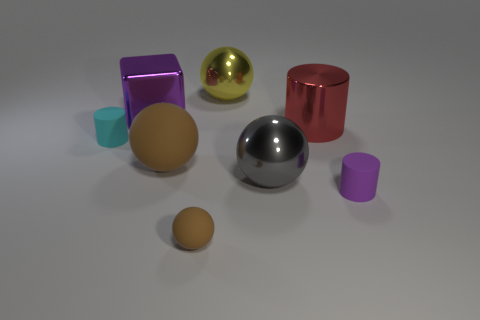Subtract all large brown balls. How many balls are left? 3 Subtract 1 blocks. How many blocks are left? 0 Add 1 big yellow matte blocks. How many objects exist? 9 Subtract all red cylinders. How many cylinders are left? 2 Subtract all cylinders. How many objects are left? 5 Add 7 large metal blocks. How many large metal blocks exist? 8 Subtract 0 blue cubes. How many objects are left? 8 Subtract all green cylinders. Subtract all gray balls. How many cylinders are left? 3 Subtract all green cubes. How many gray balls are left? 1 Subtract all small brown balls. Subtract all purple matte things. How many objects are left? 6 